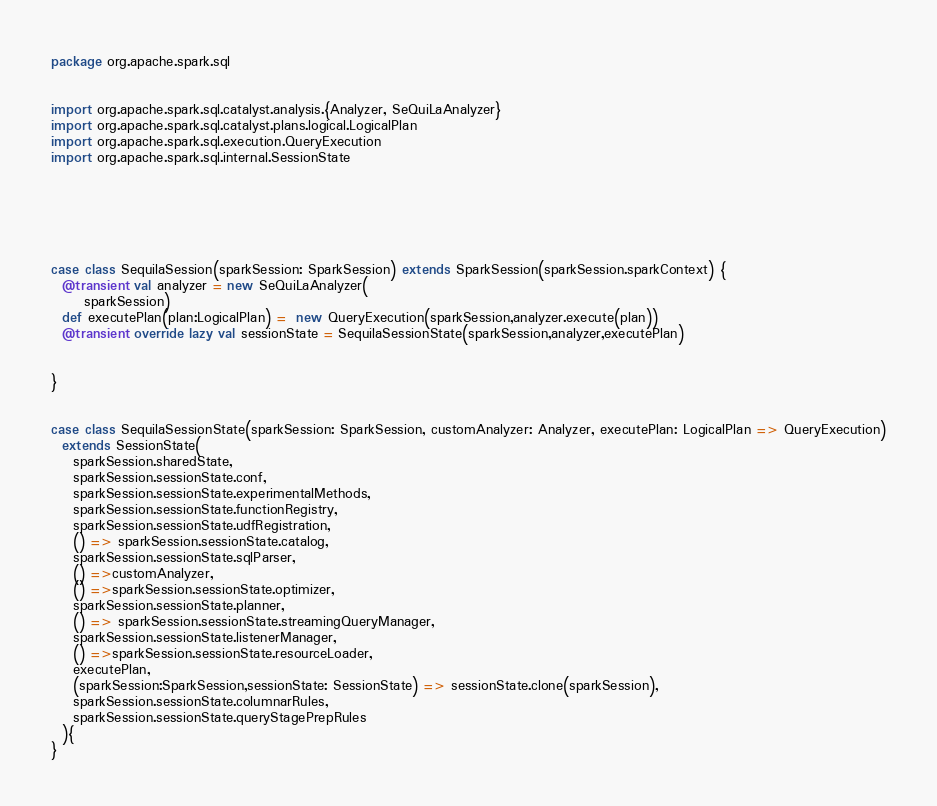Convert code to text. <code><loc_0><loc_0><loc_500><loc_500><_Scala_>package org.apache.spark.sql


import org.apache.spark.sql.catalyst.analysis.{Analyzer, SeQuiLaAnalyzer}
import org.apache.spark.sql.catalyst.plans.logical.LogicalPlan
import org.apache.spark.sql.execution.QueryExecution
import org.apache.spark.sql.internal.SessionState






case class SequilaSession(sparkSession: SparkSession) extends SparkSession(sparkSession.sparkContext) {
  @transient val analyzer = new SeQuiLaAnalyzer(
      sparkSession)
  def executePlan(plan:LogicalPlan) =  new QueryExecution(sparkSession,analyzer.execute(plan))
  @transient override lazy val sessionState = SequilaSessionState(sparkSession,analyzer,executePlan)


}


case class SequilaSessionState(sparkSession: SparkSession, customAnalyzer: Analyzer, executePlan: LogicalPlan => QueryExecution)
  extends SessionState(
    sparkSession.sharedState,
    sparkSession.sessionState.conf,
    sparkSession.sessionState.experimentalMethods,
    sparkSession.sessionState.functionRegistry,
    sparkSession.sessionState.udfRegistration,
    () => sparkSession.sessionState.catalog,
    sparkSession.sessionState.sqlParser,
    () =>customAnalyzer,
    () =>sparkSession.sessionState.optimizer,
    sparkSession.sessionState.planner,
    () => sparkSession.sessionState.streamingQueryManager,
    sparkSession.sessionState.listenerManager,
    () =>sparkSession.sessionState.resourceLoader,
    executePlan,
    (sparkSession:SparkSession,sessionState: SessionState) => sessionState.clone(sparkSession),
    sparkSession.sessionState.columnarRules,
    sparkSession.sessionState.queryStagePrepRules
  ){
}
</code> 